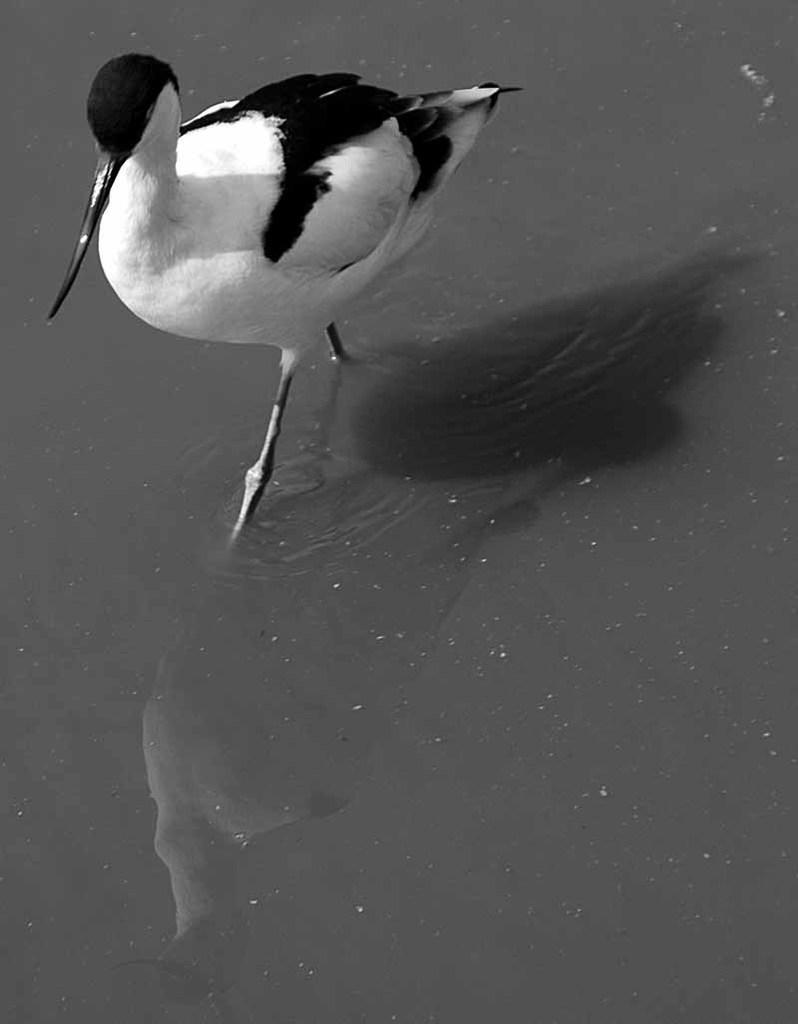Describe this image in one or two sentences. Here in this picture we can see a water bird present in the water. 